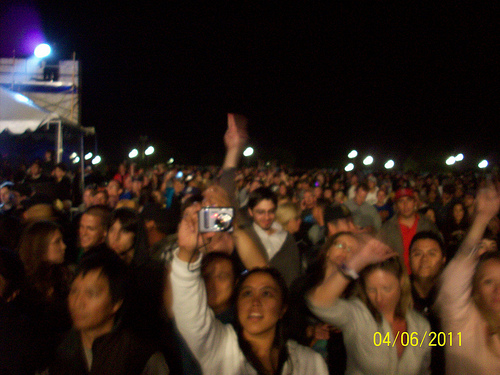<image>
Is the sky behind the light? Yes. From this viewpoint, the sky is positioned behind the light, with the light partially or fully occluding the sky. 